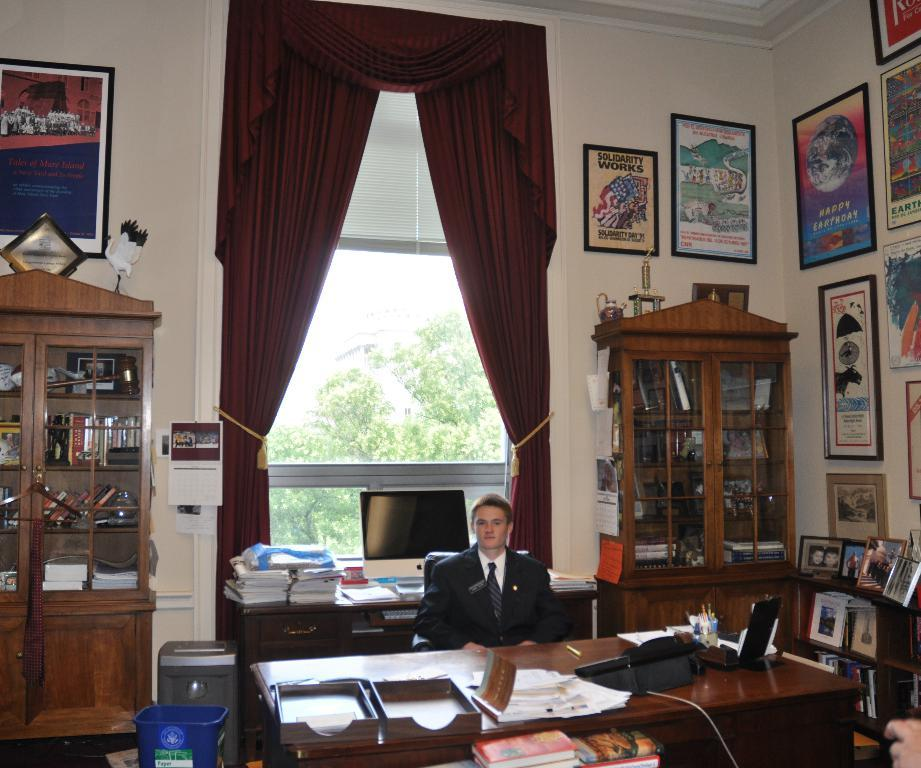<image>
Provide a brief description of the given image. apple branded monitor behind man sitting at a wooden desk. 